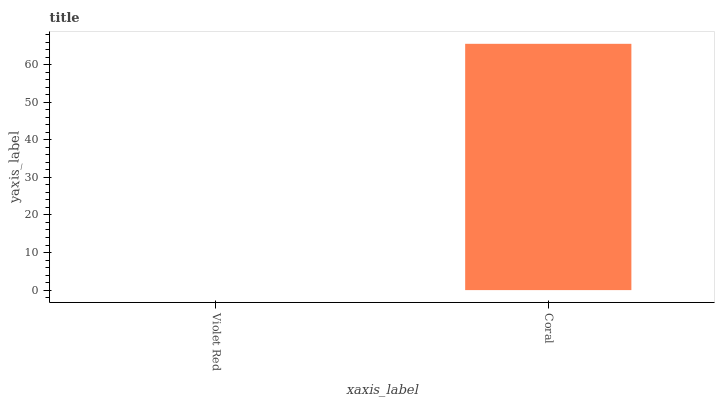Is Violet Red the minimum?
Answer yes or no. Yes. Is Coral the maximum?
Answer yes or no. Yes. Is Coral the minimum?
Answer yes or no. No. Is Coral greater than Violet Red?
Answer yes or no. Yes. Is Violet Red less than Coral?
Answer yes or no. Yes. Is Violet Red greater than Coral?
Answer yes or no. No. Is Coral less than Violet Red?
Answer yes or no. No. Is Coral the high median?
Answer yes or no. Yes. Is Violet Red the low median?
Answer yes or no. Yes. Is Violet Red the high median?
Answer yes or no. No. Is Coral the low median?
Answer yes or no. No. 